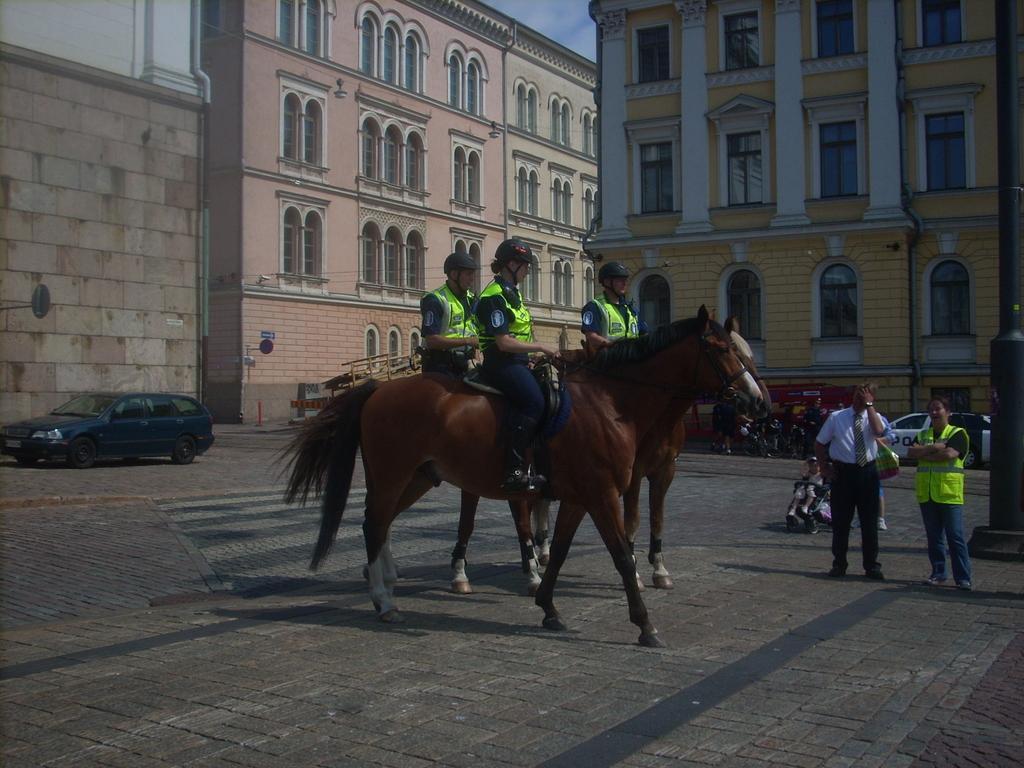In one or two sentences, can you explain what this image depicts? In this image we can see many buildings, there are windows, there are horses on the ground, there are persons sitting on it, there are persons standing, there are cars on the road, there is a sky. 